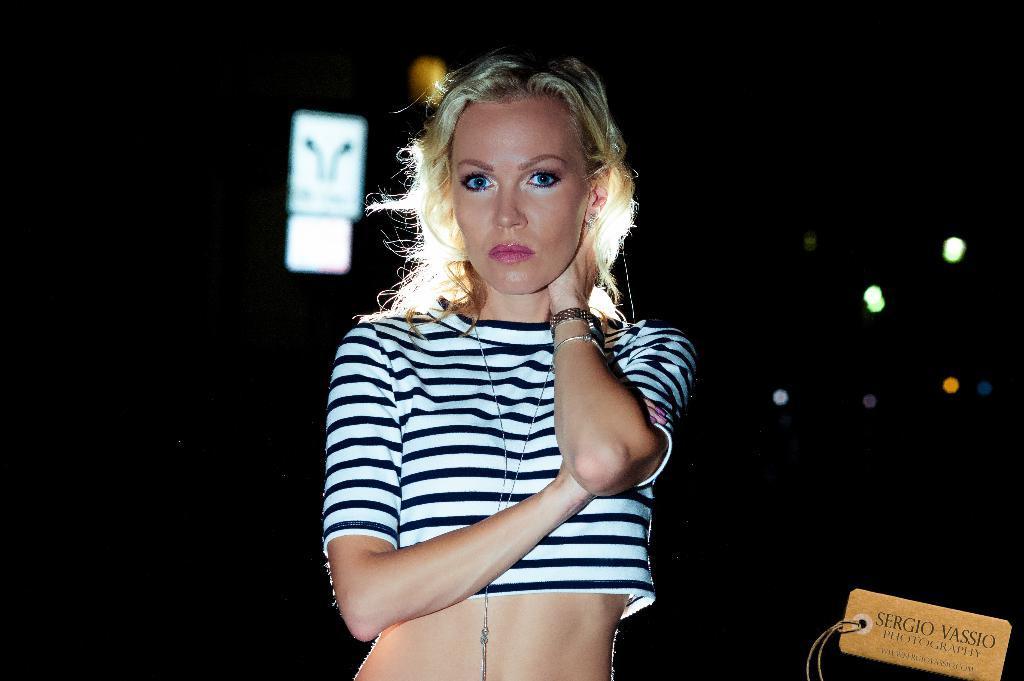Could you give a brief overview of what you see in this image? In this image there is a woman standing , and there is dark background and a watermark on the image. 